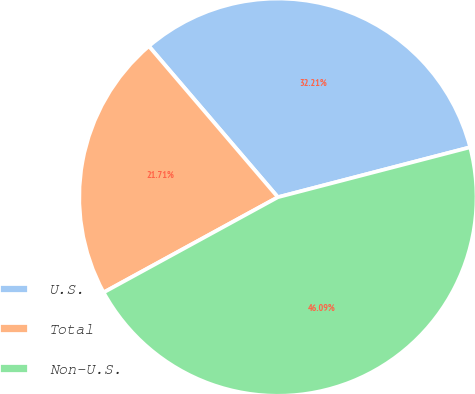<chart> <loc_0><loc_0><loc_500><loc_500><pie_chart><fcel>U.S.<fcel>Total<fcel>Non-U.S.<nl><fcel>32.21%<fcel>21.71%<fcel>46.09%<nl></chart> 